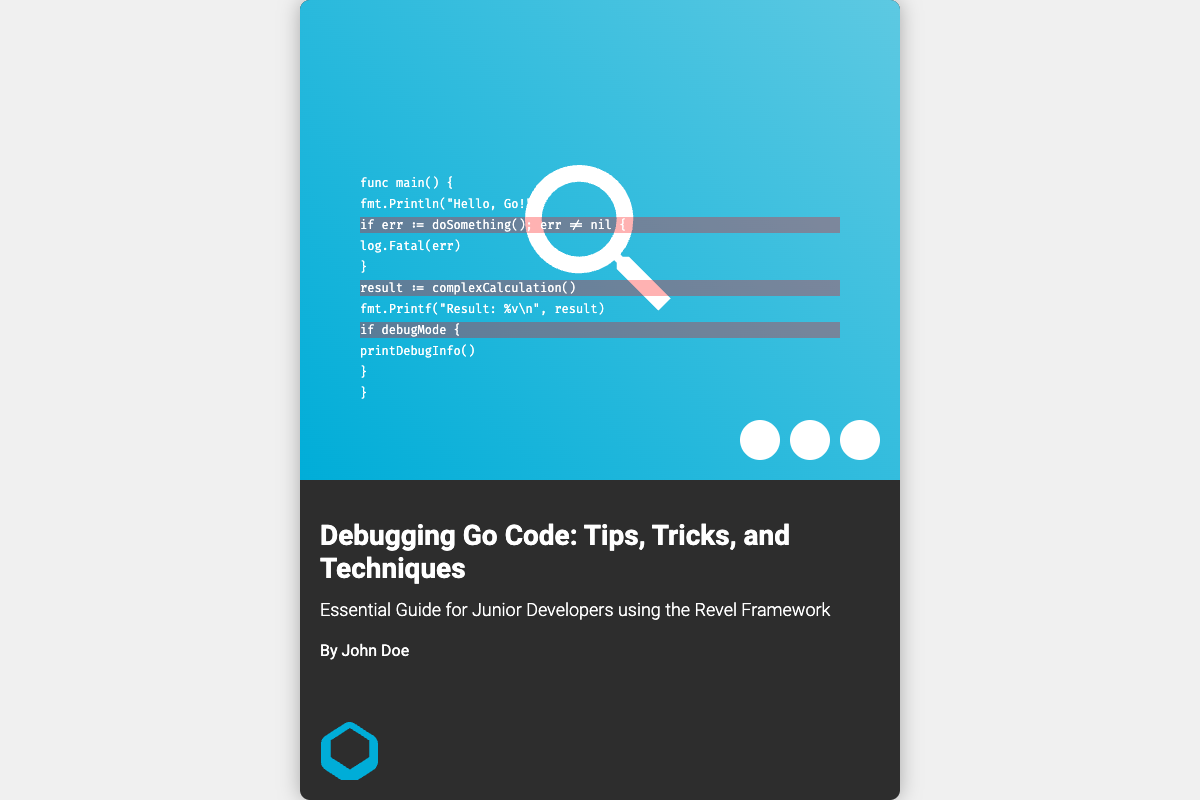What is the title of the book? The title of the book is prominently displayed on the cover.
Answer: Debugging Go Code: Tips, Tricks, and Techniques Who is the author of the book? The author's name appears in the book's information section.
Answer: John Doe What is the subtitle of the book? The subtitle provides additional context about the book's content.
Answer: Essential Guide for Junior Developers using the Revel Framework What primary programming language is the book focused on? The book's content is centered around a specific programming language.
Answer: Go How many highlighted error lines are shown in the code? There are three lines that are highlighted to indicate errors or important points.
Answer: three What shapes are represented as debugging tools on the cover? The icons on the cover represent various debugging tools.
Answer: circles What font is used for the code lines? The font style adds to the technical feel of the code presentation.
Answer: Fira Code What position does the magnifying glass occupy on the cover? The positioning of the magnifying glass emphasizes the act of examining code closely.
Answer: center In which section of the cover is the Go Gopher located? The Go Gopher is typically a mascot for the Go programming language and is placed strategically on the cover.
Answer: bottom left 